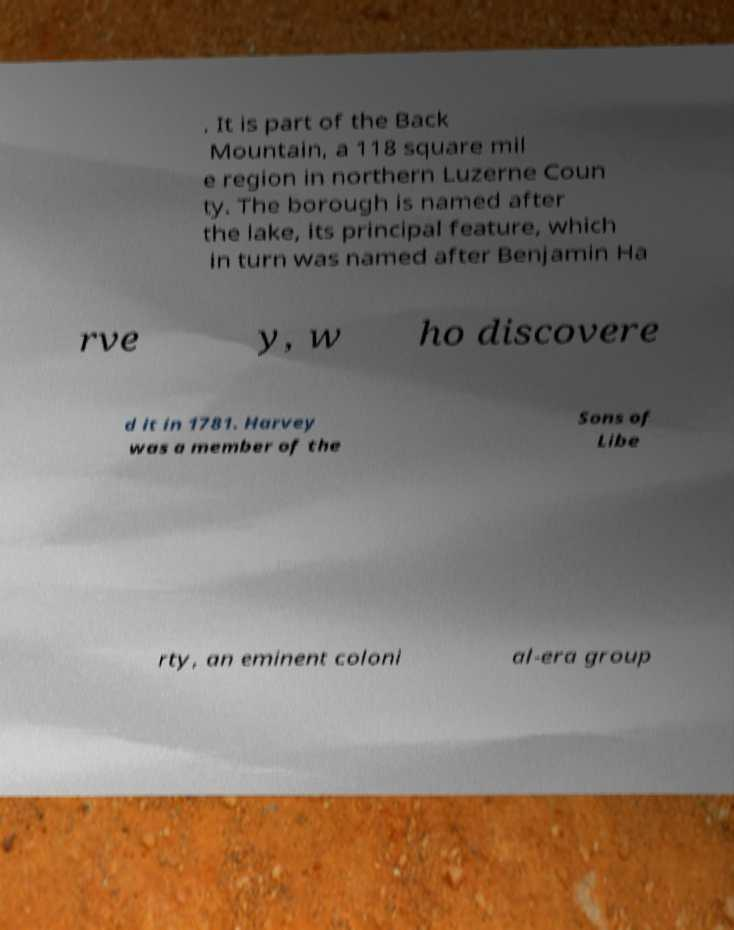Please read and relay the text visible in this image. What does it say? . It is part of the Back Mountain, a 118 square mil e region in northern Luzerne Coun ty. The borough is named after the lake, its principal feature, which in turn was named after Benjamin Ha rve y, w ho discovere d it in 1781. Harvey was a member of the Sons of Libe rty, an eminent coloni al-era group 